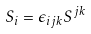<formula> <loc_0><loc_0><loc_500><loc_500>S _ { i } = \epsilon _ { i j k } S ^ { j k }</formula> 